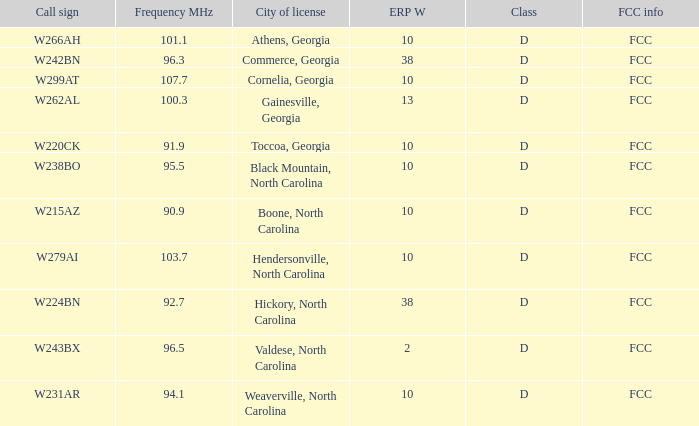7? FCC. 